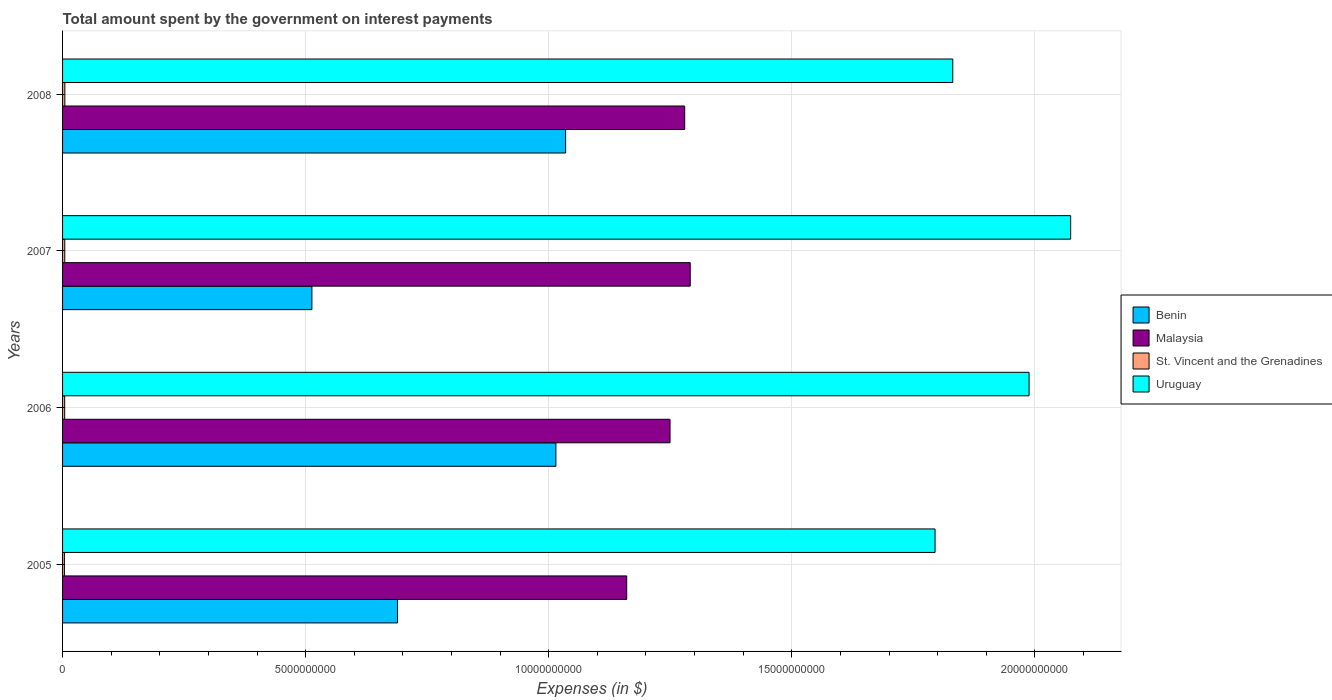Are the number of bars per tick equal to the number of legend labels?
Provide a short and direct response. Yes. How many bars are there on the 1st tick from the top?
Provide a short and direct response. 4. In how many cases, is the number of bars for a given year not equal to the number of legend labels?
Your answer should be compact. 0. What is the amount spent on interest payments by the government in St. Vincent and the Grenadines in 2006?
Provide a succinct answer. 4.32e+07. Across all years, what is the maximum amount spent on interest payments by the government in Uruguay?
Provide a short and direct response. 2.07e+1. Across all years, what is the minimum amount spent on interest payments by the government in Benin?
Offer a very short reply. 5.13e+09. In which year was the amount spent on interest payments by the government in Benin maximum?
Provide a short and direct response. 2008. What is the total amount spent on interest payments by the government in St. Vincent and the Grenadines in the graph?
Provide a short and direct response. 1.73e+08. What is the difference between the amount spent on interest payments by the government in Uruguay in 2006 and that in 2007?
Ensure brevity in your answer.  -8.55e+08. What is the difference between the amount spent on interest payments by the government in Uruguay in 2005 and the amount spent on interest payments by the government in Benin in 2008?
Keep it short and to the point. 7.60e+09. What is the average amount spent on interest payments by the government in Uruguay per year?
Give a very brief answer. 1.92e+1. In the year 2008, what is the difference between the amount spent on interest payments by the government in Benin and amount spent on interest payments by the government in Malaysia?
Provide a short and direct response. -2.45e+09. In how many years, is the amount spent on interest payments by the government in Uruguay greater than 7000000000 $?
Provide a succinct answer. 4. What is the ratio of the amount spent on interest payments by the government in St. Vincent and the Grenadines in 2006 to that in 2008?
Your response must be concise. 0.92. Is the difference between the amount spent on interest payments by the government in Benin in 2006 and 2008 greater than the difference between the amount spent on interest payments by the government in Malaysia in 2006 and 2008?
Give a very brief answer. Yes. What is the difference between the highest and the second highest amount spent on interest payments by the government in Uruguay?
Provide a short and direct response. 8.55e+08. What is the difference between the highest and the lowest amount spent on interest payments by the government in Uruguay?
Provide a succinct answer. 2.79e+09. Is the sum of the amount spent on interest payments by the government in Malaysia in 2006 and 2008 greater than the maximum amount spent on interest payments by the government in St. Vincent and the Grenadines across all years?
Provide a short and direct response. Yes. What does the 1st bar from the top in 2007 represents?
Your answer should be very brief. Uruguay. What does the 2nd bar from the bottom in 2006 represents?
Your response must be concise. Malaysia. Are all the bars in the graph horizontal?
Your response must be concise. Yes. Are the values on the major ticks of X-axis written in scientific E-notation?
Keep it short and to the point. No. How are the legend labels stacked?
Provide a succinct answer. Vertical. What is the title of the graph?
Your answer should be compact. Total amount spent by the government on interest payments. What is the label or title of the X-axis?
Offer a terse response. Expenses (in $). What is the label or title of the Y-axis?
Keep it short and to the point. Years. What is the Expenses (in $) in Benin in 2005?
Keep it short and to the point. 6.89e+09. What is the Expenses (in $) of Malaysia in 2005?
Your answer should be very brief. 1.16e+1. What is the Expenses (in $) of St. Vincent and the Grenadines in 2005?
Give a very brief answer. 3.80e+07. What is the Expenses (in $) of Uruguay in 2005?
Offer a terse response. 1.79e+1. What is the Expenses (in $) of Benin in 2006?
Your response must be concise. 1.01e+1. What is the Expenses (in $) in Malaysia in 2006?
Your response must be concise. 1.25e+1. What is the Expenses (in $) of St. Vincent and the Grenadines in 2006?
Your answer should be very brief. 4.32e+07. What is the Expenses (in $) in Uruguay in 2006?
Offer a very short reply. 1.99e+1. What is the Expenses (in $) in Benin in 2007?
Make the answer very short. 5.13e+09. What is the Expenses (in $) in Malaysia in 2007?
Make the answer very short. 1.29e+1. What is the Expenses (in $) in St. Vincent and the Grenadines in 2007?
Ensure brevity in your answer.  4.53e+07. What is the Expenses (in $) of Uruguay in 2007?
Offer a very short reply. 2.07e+1. What is the Expenses (in $) of Benin in 2008?
Your answer should be compact. 1.03e+1. What is the Expenses (in $) in Malaysia in 2008?
Your answer should be compact. 1.28e+1. What is the Expenses (in $) in St. Vincent and the Grenadines in 2008?
Give a very brief answer. 4.68e+07. What is the Expenses (in $) of Uruguay in 2008?
Ensure brevity in your answer.  1.83e+1. Across all years, what is the maximum Expenses (in $) of Benin?
Your answer should be very brief. 1.03e+1. Across all years, what is the maximum Expenses (in $) in Malaysia?
Provide a short and direct response. 1.29e+1. Across all years, what is the maximum Expenses (in $) in St. Vincent and the Grenadines?
Keep it short and to the point. 4.68e+07. Across all years, what is the maximum Expenses (in $) of Uruguay?
Provide a short and direct response. 2.07e+1. Across all years, what is the minimum Expenses (in $) in Benin?
Your response must be concise. 5.13e+09. Across all years, what is the minimum Expenses (in $) in Malaysia?
Offer a terse response. 1.16e+1. Across all years, what is the minimum Expenses (in $) of St. Vincent and the Grenadines?
Your response must be concise. 3.80e+07. Across all years, what is the minimum Expenses (in $) in Uruguay?
Your answer should be compact. 1.79e+1. What is the total Expenses (in $) of Benin in the graph?
Make the answer very short. 3.25e+1. What is the total Expenses (in $) in Malaysia in the graph?
Give a very brief answer. 4.98e+1. What is the total Expenses (in $) in St. Vincent and the Grenadines in the graph?
Make the answer very short. 1.73e+08. What is the total Expenses (in $) of Uruguay in the graph?
Ensure brevity in your answer.  7.69e+1. What is the difference between the Expenses (in $) in Benin in 2005 and that in 2006?
Keep it short and to the point. -3.26e+09. What is the difference between the Expenses (in $) of Malaysia in 2005 and that in 2006?
Your answer should be very brief. -8.91e+08. What is the difference between the Expenses (in $) in St. Vincent and the Grenadines in 2005 and that in 2006?
Offer a terse response. -5.20e+06. What is the difference between the Expenses (in $) of Uruguay in 2005 and that in 2006?
Offer a terse response. -1.93e+09. What is the difference between the Expenses (in $) in Benin in 2005 and that in 2007?
Ensure brevity in your answer.  1.76e+09. What is the difference between the Expenses (in $) in Malaysia in 2005 and that in 2007?
Provide a short and direct response. -1.31e+09. What is the difference between the Expenses (in $) in St. Vincent and the Grenadines in 2005 and that in 2007?
Give a very brief answer. -7.30e+06. What is the difference between the Expenses (in $) of Uruguay in 2005 and that in 2007?
Your answer should be very brief. -2.79e+09. What is the difference between the Expenses (in $) of Benin in 2005 and that in 2008?
Give a very brief answer. -3.46e+09. What is the difference between the Expenses (in $) in Malaysia in 2005 and that in 2008?
Your response must be concise. -1.19e+09. What is the difference between the Expenses (in $) of St. Vincent and the Grenadines in 2005 and that in 2008?
Provide a short and direct response. -8.80e+06. What is the difference between the Expenses (in $) in Uruguay in 2005 and that in 2008?
Offer a very short reply. -3.64e+08. What is the difference between the Expenses (in $) of Benin in 2006 and that in 2007?
Provide a short and direct response. 5.02e+09. What is the difference between the Expenses (in $) in Malaysia in 2006 and that in 2007?
Make the answer very short. -4.15e+08. What is the difference between the Expenses (in $) of St. Vincent and the Grenadines in 2006 and that in 2007?
Offer a very short reply. -2.10e+06. What is the difference between the Expenses (in $) of Uruguay in 2006 and that in 2007?
Provide a short and direct response. -8.55e+08. What is the difference between the Expenses (in $) in Benin in 2006 and that in 2008?
Provide a short and direct response. -2.00e+08. What is the difference between the Expenses (in $) of Malaysia in 2006 and that in 2008?
Ensure brevity in your answer.  -3.01e+08. What is the difference between the Expenses (in $) in St. Vincent and the Grenadines in 2006 and that in 2008?
Your answer should be very brief. -3.60e+06. What is the difference between the Expenses (in $) of Uruguay in 2006 and that in 2008?
Ensure brevity in your answer.  1.57e+09. What is the difference between the Expenses (in $) in Benin in 2007 and that in 2008?
Give a very brief answer. -5.22e+09. What is the difference between the Expenses (in $) in Malaysia in 2007 and that in 2008?
Make the answer very short. 1.14e+08. What is the difference between the Expenses (in $) of St. Vincent and the Grenadines in 2007 and that in 2008?
Provide a short and direct response. -1.50e+06. What is the difference between the Expenses (in $) in Uruguay in 2007 and that in 2008?
Give a very brief answer. 2.42e+09. What is the difference between the Expenses (in $) of Benin in 2005 and the Expenses (in $) of Malaysia in 2006?
Your response must be concise. -5.61e+09. What is the difference between the Expenses (in $) in Benin in 2005 and the Expenses (in $) in St. Vincent and the Grenadines in 2006?
Provide a succinct answer. 6.85e+09. What is the difference between the Expenses (in $) of Benin in 2005 and the Expenses (in $) of Uruguay in 2006?
Provide a short and direct response. -1.30e+1. What is the difference between the Expenses (in $) in Malaysia in 2005 and the Expenses (in $) in St. Vincent and the Grenadines in 2006?
Your answer should be compact. 1.16e+1. What is the difference between the Expenses (in $) of Malaysia in 2005 and the Expenses (in $) of Uruguay in 2006?
Give a very brief answer. -8.28e+09. What is the difference between the Expenses (in $) of St. Vincent and the Grenadines in 2005 and the Expenses (in $) of Uruguay in 2006?
Offer a very short reply. -1.98e+1. What is the difference between the Expenses (in $) in Benin in 2005 and the Expenses (in $) in Malaysia in 2007?
Keep it short and to the point. -6.02e+09. What is the difference between the Expenses (in $) in Benin in 2005 and the Expenses (in $) in St. Vincent and the Grenadines in 2007?
Keep it short and to the point. 6.84e+09. What is the difference between the Expenses (in $) of Benin in 2005 and the Expenses (in $) of Uruguay in 2007?
Give a very brief answer. -1.38e+1. What is the difference between the Expenses (in $) in Malaysia in 2005 and the Expenses (in $) in St. Vincent and the Grenadines in 2007?
Offer a terse response. 1.16e+1. What is the difference between the Expenses (in $) in Malaysia in 2005 and the Expenses (in $) in Uruguay in 2007?
Offer a very short reply. -9.13e+09. What is the difference between the Expenses (in $) of St. Vincent and the Grenadines in 2005 and the Expenses (in $) of Uruguay in 2007?
Provide a succinct answer. -2.07e+1. What is the difference between the Expenses (in $) in Benin in 2005 and the Expenses (in $) in Malaysia in 2008?
Provide a succinct answer. -5.91e+09. What is the difference between the Expenses (in $) of Benin in 2005 and the Expenses (in $) of St. Vincent and the Grenadines in 2008?
Provide a short and direct response. 6.84e+09. What is the difference between the Expenses (in $) in Benin in 2005 and the Expenses (in $) in Uruguay in 2008?
Keep it short and to the point. -1.14e+1. What is the difference between the Expenses (in $) of Malaysia in 2005 and the Expenses (in $) of St. Vincent and the Grenadines in 2008?
Provide a short and direct response. 1.16e+1. What is the difference between the Expenses (in $) in Malaysia in 2005 and the Expenses (in $) in Uruguay in 2008?
Your answer should be compact. -6.71e+09. What is the difference between the Expenses (in $) in St. Vincent and the Grenadines in 2005 and the Expenses (in $) in Uruguay in 2008?
Provide a succinct answer. -1.83e+1. What is the difference between the Expenses (in $) of Benin in 2006 and the Expenses (in $) of Malaysia in 2007?
Provide a short and direct response. -2.76e+09. What is the difference between the Expenses (in $) of Benin in 2006 and the Expenses (in $) of St. Vincent and the Grenadines in 2007?
Offer a very short reply. 1.01e+1. What is the difference between the Expenses (in $) in Benin in 2006 and the Expenses (in $) in Uruguay in 2007?
Your response must be concise. -1.06e+1. What is the difference between the Expenses (in $) in Malaysia in 2006 and the Expenses (in $) in St. Vincent and the Grenadines in 2007?
Ensure brevity in your answer.  1.25e+1. What is the difference between the Expenses (in $) of Malaysia in 2006 and the Expenses (in $) of Uruguay in 2007?
Offer a very short reply. -8.24e+09. What is the difference between the Expenses (in $) of St. Vincent and the Grenadines in 2006 and the Expenses (in $) of Uruguay in 2007?
Provide a succinct answer. -2.07e+1. What is the difference between the Expenses (in $) in Benin in 2006 and the Expenses (in $) in Malaysia in 2008?
Make the answer very short. -2.65e+09. What is the difference between the Expenses (in $) of Benin in 2006 and the Expenses (in $) of St. Vincent and the Grenadines in 2008?
Ensure brevity in your answer.  1.01e+1. What is the difference between the Expenses (in $) of Benin in 2006 and the Expenses (in $) of Uruguay in 2008?
Keep it short and to the point. -8.16e+09. What is the difference between the Expenses (in $) in Malaysia in 2006 and the Expenses (in $) in St. Vincent and the Grenadines in 2008?
Your answer should be very brief. 1.24e+1. What is the difference between the Expenses (in $) of Malaysia in 2006 and the Expenses (in $) of Uruguay in 2008?
Provide a succinct answer. -5.82e+09. What is the difference between the Expenses (in $) in St. Vincent and the Grenadines in 2006 and the Expenses (in $) in Uruguay in 2008?
Your answer should be compact. -1.83e+1. What is the difference between the Expenses (in $) of Benin in 2007 and the Expenses (in $) of Malaysia in 2008?
Make the answer very short. -7.67e+09. What is the difference between the Expenses (in $) of Benin in 2007 and the Expenses (in $) of St. Vincent and the Grenadines in 2008?
Your answer should be compact. 5.08e+09. What is the difference between the Expenses (in $) of Benin in 2007 and the Expenses (in $) of Uruguay in 2008?
Provide a short and direct response. -1.32e+1. What is the difference between the Expenses (in $) of Malaysia in 2007 and the Expenses (in $) of St. Vincent and the Grenadines in 2008?
Offer a terse response. 1.29e+1. What is the difference between the Expenses (in $) of Malaysia in 2007 and the Expenses (in $) of Uruguay in 2008?
Provide a short and direct response. -5.40e+09. What is the difference between the Expenses (in $) of St. Vincent and the Grenadines in 2007 and the Expenses (in $) of Uruguay in 2008?
Provide a short and direct response. -1.83e+1. What is the average Expenses (in $) of Benin per year?
Offer a very short reply. 8.13e+09. What is the average Expenses (in $) of Malaysia per year?
Your answer should be compact. 1.25e+1. What is the average Expenses (in $) in St. Vincent and the Grenadines per year?
Ensure brevity in your answer.  4.33e+07. What is the average Expenses (in $) in Uruguay per year?
Your answer should be compact. 1.92e+1. In the year 2005, what is the difference between the Expenses (in $) in Benin and Expenses (in $) in Malaysia?
Offer a very short reply. -4.71e+09. In the year 2005, what is the difference between the Expenses (in $) of Benin and Expenses (in $) of St. Vincent and the Grenadines?
Your answer should be very brief. 6.85e+09. In the year 2005, what is the difference between the Expenses (in $) in Benin and Expenses (in $) in Uruguay?
Offer a terse response. -1.11e+1. In the year 2005, what is the difference between the Expenses (in $) of Malaysia and Expenses (in $) of St. Vincent and the Grenadines?
Your answer should be very brief. 1.16e+1. In the year 2005, what is the difference between the Expenses (in $) of Malaysia and Expenses (in $) of Uruguay?
Ensure brevity in your answer.  -6.34e+09. In the year 2005, what is the difference between the Expenses (in $) in St. Vincent and the Grenadines and Expenses (in $) in Uruguay?
Your answer should be very brief. -1.79e+1. In the year 2006, what is the difference between the Expenses (in $) of Benin and Expenses (in $) of Malaysia?
Your answer should be very brief. -2.35e+09. In the year 2006, what is the difference between the Expenses (in $) of Benin and Expenses (in $) of St. Vincent and the Grenadines?
Ensure brevity in your answer.  1.01e+1. In the year 2006, what is the difference between the Expenses (in $) in Benin and Expenses (in $) in Uruguay?
Offer a terse response. -9.73e+09. In the year 2006, what is the difference between the Expenses (in $) of Malaysia and Expenses (in $) of St. Vincent and the Grenadines?
Provide a succinct answer. 1.25e+1. In the year 2006, what is the difference between the Expenses (in $) in Malaysia and Expenses (in $) in Uruguay?
Offer a very short reply. -7.39e+09. In the year 2006, what is the difference between the Expenses (in $) of St. Vincent and the Grenadines and Expenses (in $) of Uruguay?
Keep it short and to the point. -1.98e+1. In the year 2007, what is the difference between the Expenses (in $) of Benin and Expenses (in $) of Malaysia?
Give a very brief answer. -7.78e+09. In the year 2007, what is the difference between the Expenses (in $) of Benin and Expenses (in $) of St. Vincent and the Grenadines?
Offer a very short reply. 5.08e+09. In the year 2007, what is the difference between the Expenses (in $) in Benin and Expenses (in $) in Uruguay?
Make the answer very short. -1.56e+1. In the year 2007, what is the difference between the Expenses (in $) of Malaysia and Expenses (in $) of St. Vincent and the Grenadines?
Provide a short and direct response. 1.29e+1. In the year 2007, what is the difference between the Expenses (in $) in Malaysia and Expenses (in $) in Uruguay?
Make the answer very short. -7.82e+09. In the year 2007, what is the difference between the Expenses (in $) in St. Vincent and the Grenadines and Expenses (in $) in Uruguay?
Ensure brevity in your answer.  -2.07e+1. In the year 2008, what is the difference between the Expenses (in $) of Benin and Expenses (in $) of Malaysia?
Your answer should be very brief. -2.45e+09. In the year 2008, what is the difference between the Expenses (in $) in Benin and Expenses (in $) in St. Vincent and the Grenadines?
Your answer should be very brief. 1.03e+1. In the year 2008, what is the difference between the Expenses (in $) in Benin and Expenses (in $) in Uruguay?
Ensure brevity in your answer.  -7.96e+09. In the year 2008, what is the difference between the Expenses (in $) in Malaysia and Expenses (in $) in St. Vincent and the Grenadines?
Provide a succinct answer. 1.28e+1. In the year 2008, what is the difference between the Expenses (in $) of Malaysia and Expenses (in $) of Uruguay?
Keep it short and to the point. -5.51e+09. In the year 2008, what is the difference between the Expenses (in $) of St. Vincent and the Grenadines and Expenses (in $) of Uruguay?
Offer a very short reply. -1.83e+1. What is the ratio of the Expenses (in $) in Benin in 2005 to that in 2006?
Offer a very short reply. 0.68. What is the ratio of the Expenses (in $) of Malaysia in 2005 to that in 2006?
Provide a succinct answer. 0.93. What is the ratio of the Expenses (in $) of St. Vincent and the Grenadines in 2005 to that in 2006?
Ensure brevity in your answer.  0.88. What is the ratio of the Expenses (in $) of Uruguay in 2005 to that in 2006?
Your answer should be compact. 0.9. What is the ratio of the Expenses (in $) in Benin in 2005 to that in 2007?
Give a very brief answer. 1.34. What is the ratio of the Expenses (in $) of Malaysia in 2005 to that in 2007?
Your answer should be compact. 0.9. What is the ratio of the Expenses (in $) of St. Vincent and the Grenadines in 2005 to that in 2007?
Offer a very short reply. 0.84. What is the ratio of the Expenses (in $) of Uruguay in 2005 to that in 2007?
Offer a very short reply. 0.87. What is the ratio of the Expenses (in $) in Benin in 2005 to that in 2008?
Ensure brevity in your answer.  0.67. What is the ratio of the Expenses (in $) in Malaysia in 2005 to that in 2008?
Make the answer very short. 0.91. What is the ratio of the Expenses (in $) of St. Vincent and the Grenadines in 2005 to that in 2008?
Offer a very short reply. 0.81. What is the ratio of the Expenses (in $) of Uruguay in 2005 to that in 2008?
Your response must be concise. 0.98. What is the ratio of the Expenses (in $) of Benin in 2006 to that in 2007?
Provide a succinct answer. 1.98. What is the ratio of the Expenses (in $) of Malaysia in 2006 to that in 2007?
Ensure brevity in your answer.  0.97. What is the ratio of the Expenses (in $) in St. Vincent and the Grenadines in 2006 to that in 2007?
Offer a terse response. 0.95. What is the ratio of the Expenses (in $) in Uruguay in 2006 to that in 2007?
Provide a succinct answer. 0.96. What is the ratio of the Expenses (in $) of Benin in 2006 to that in 2008?
Your answer should be compact. 0.98. What is the ratio of the Expenses (in $) in Malaysia in 2006 to that in 2008?
Provide a short and direct response. 0.98. What is the ratio of the Expenses (in $) in St. Vincent and the Grenadines in 2006 to that in 2008?
Your answer should be very brief. 0.92. What is the ratio of the Expenses (in $) in Uruguay in 2006 to that in 2008?
Keep it short and to the point. 1.09. What is the ratio of the Expenses (in $) of Benin in 2007 to that in 2008?
Your response must be concise. 0.5. What is the ratio of the Expenses (in $) of Malaysia in 2007 to that in 2008?
Give a very brief answer. 1.01. What is the ratio of the Expenses (in $) of St. Vincent and the Grenadines in 2007 to that in 2008?
Ensure brevity in your answer.  0.97. What is the ratio of the Expenses (in $) of Uruguay in 2007 to that in 2008?
Make the answer very short. 1.13. What is the difference between the highest and the second highest Expenses (in $) in Benin?
Your answer should be very brief. 2.00e+08. What is the difference between the highest and the second highest Expenses (in $) in Malaysia?
Ensure brevity in your answer.  1.14e+08. What is the difference between the highest and the second highest Expenses (in $) of St. Vincent and the Grenadines?
Your answer should be compact. 1.50e+06. What is the difference between the highest and the second highest Expenses (in $) of Uruguay?
Your response must be concise. 8.55e+08. What is the difference between the highest and the lowest Expenses (in $) of Benin?
Give a very brief answer. 5.22e+09. What is the difference between the highest and the lowest Expenses (in $) in Malaysia?
Provide a short and direct response. 1.31e+09. What is the difference between the highest and the lowest Expenses (in $) in St. Vincent and the Grenadines?
Make the answer very short. 8.80e+06. What is the difference between the highest and the lowest Expenses (in $) of Uruguay?
Keep it short and to the point. 2.79e+09. 